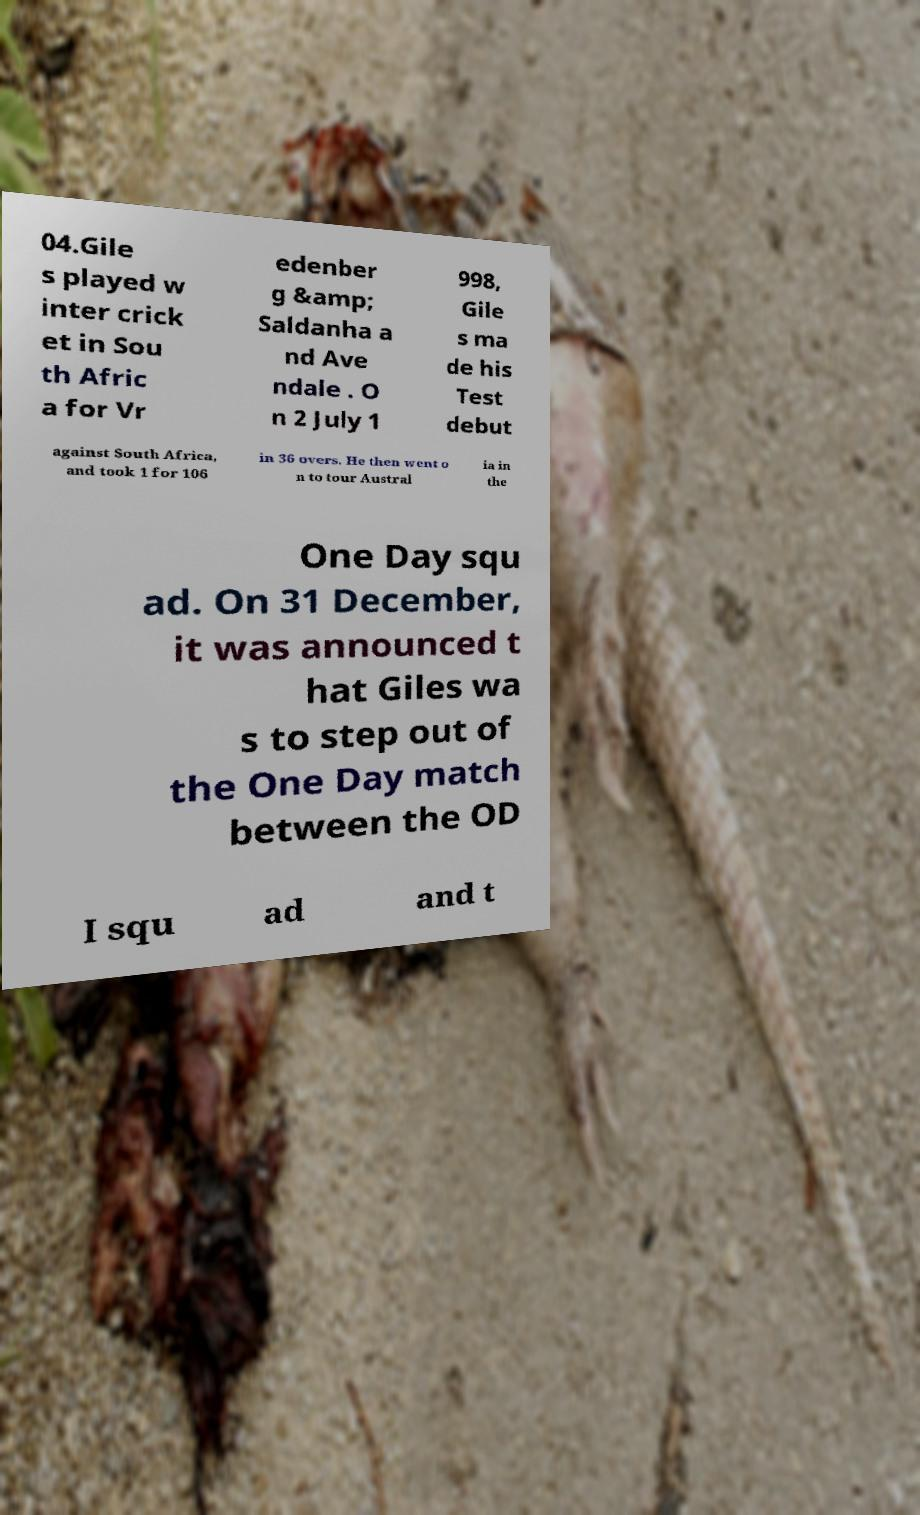What messages or text are displayed in this image? I need them in a readable, typed format. 04.Gile s played w inter crick et in Sou th Afric a for Vr edenber g &amp; Saldanha a nd Ave ndale . O n 2 July 1 998, Gile s ma de his Test debut against South Africa, and took 1 for 106 in 36 overs. He then went o n to tour Austral ia in the One Day squ ad. On 31 December, it was announced t hat Giles wa s to step out of the One Day match between the OD I squ ad and t 